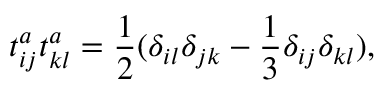<formula> <loc_0><loc_0><loc_500><loc_500>t _ { i j } ^ { a } t _ { k l } ^ { a } = \frac { 1 } { 2 } ( \delta _ { i l } \delta _ { j k } - \frac { 1 } { 3 } \delta _ { i j } \delta _ { k l } ) ,</formula> 